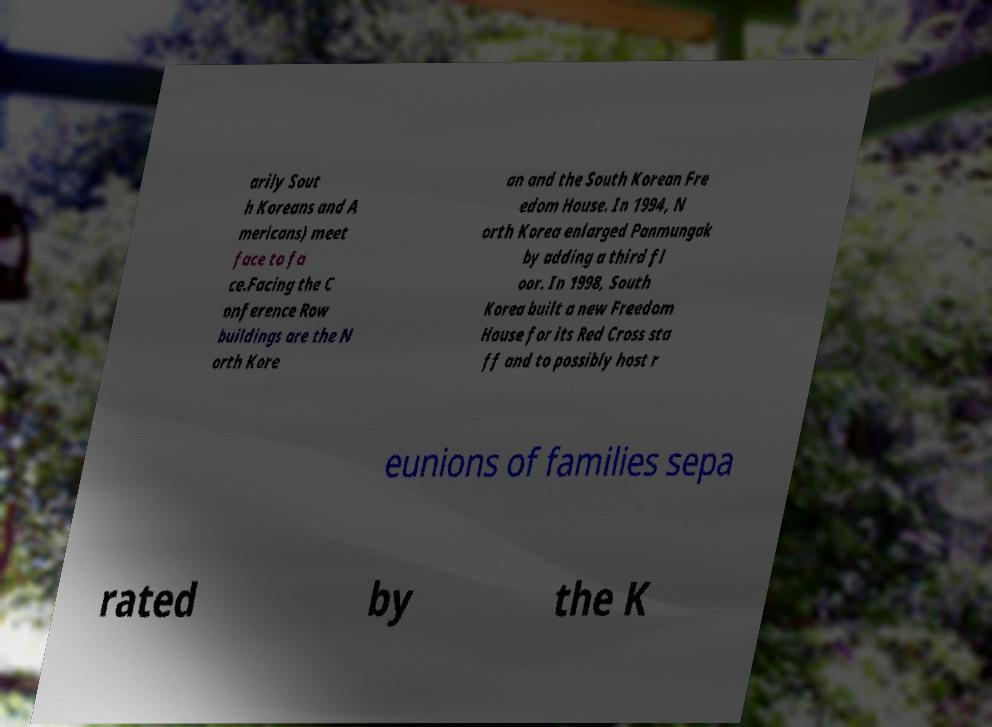Please read and relay the text visible in this image. What does it say? arily Sout h Koreans and A mericans) meet face to fa ce.Facing the C onference Row buildings are the N orth Kore an and the South Korean Fre edom House. In 1994, N orth Korea enlarged Panmungak by adding a third fl oor. In 1998, South Korea built a new Freedom House for its Red Cross sta ff and to possibly host r eunions of families sepa rated by the K 